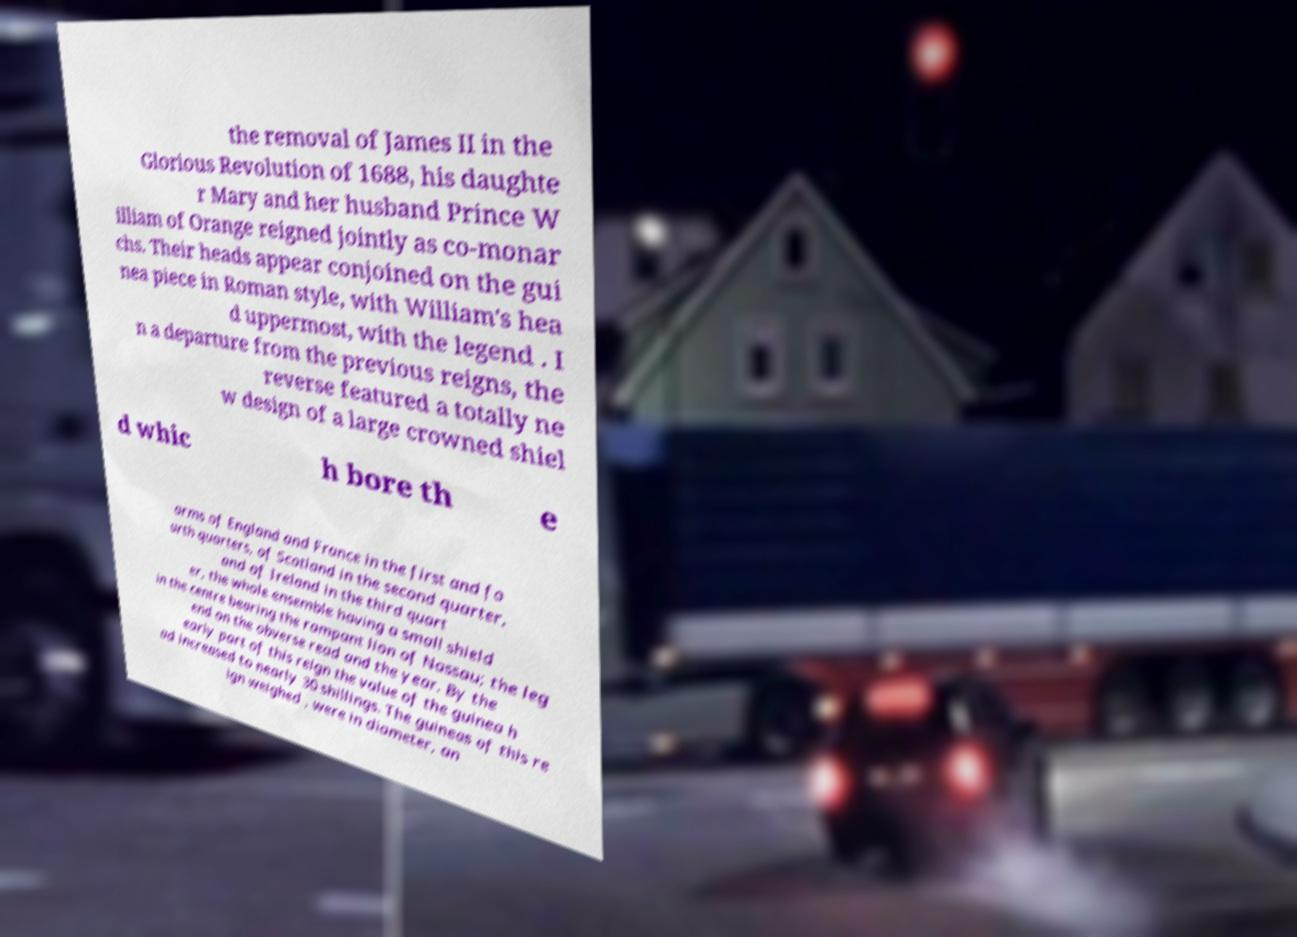Could you extract and type out the text from this image? the removal of James II in the Glorious Revolution of 1688, his daughte r Mary and her husband Prince W illiam of Orange reigned jointly as co-monar chs. Their heads appear conjoined on the gui nea piece in Roman style, with William's hea d uppermost, with the legend . I n a departure from the previous reigns, the reverse featured a totally ne w design of a large crowned shiel d whic h bore th e arms of England and France in the first and fo urth quarters, of Scotland in the second quarter, and of Ireland in the third quart er, the whole ensemble having a small shield in the centre bearing the rampant lion of Nassau; the leg end on the obverse read and the year. By the early part of this reign the value of the guinea h ad increased to nearly 30 shillings. The guineas of this re ign weighed , were in diameter, an 